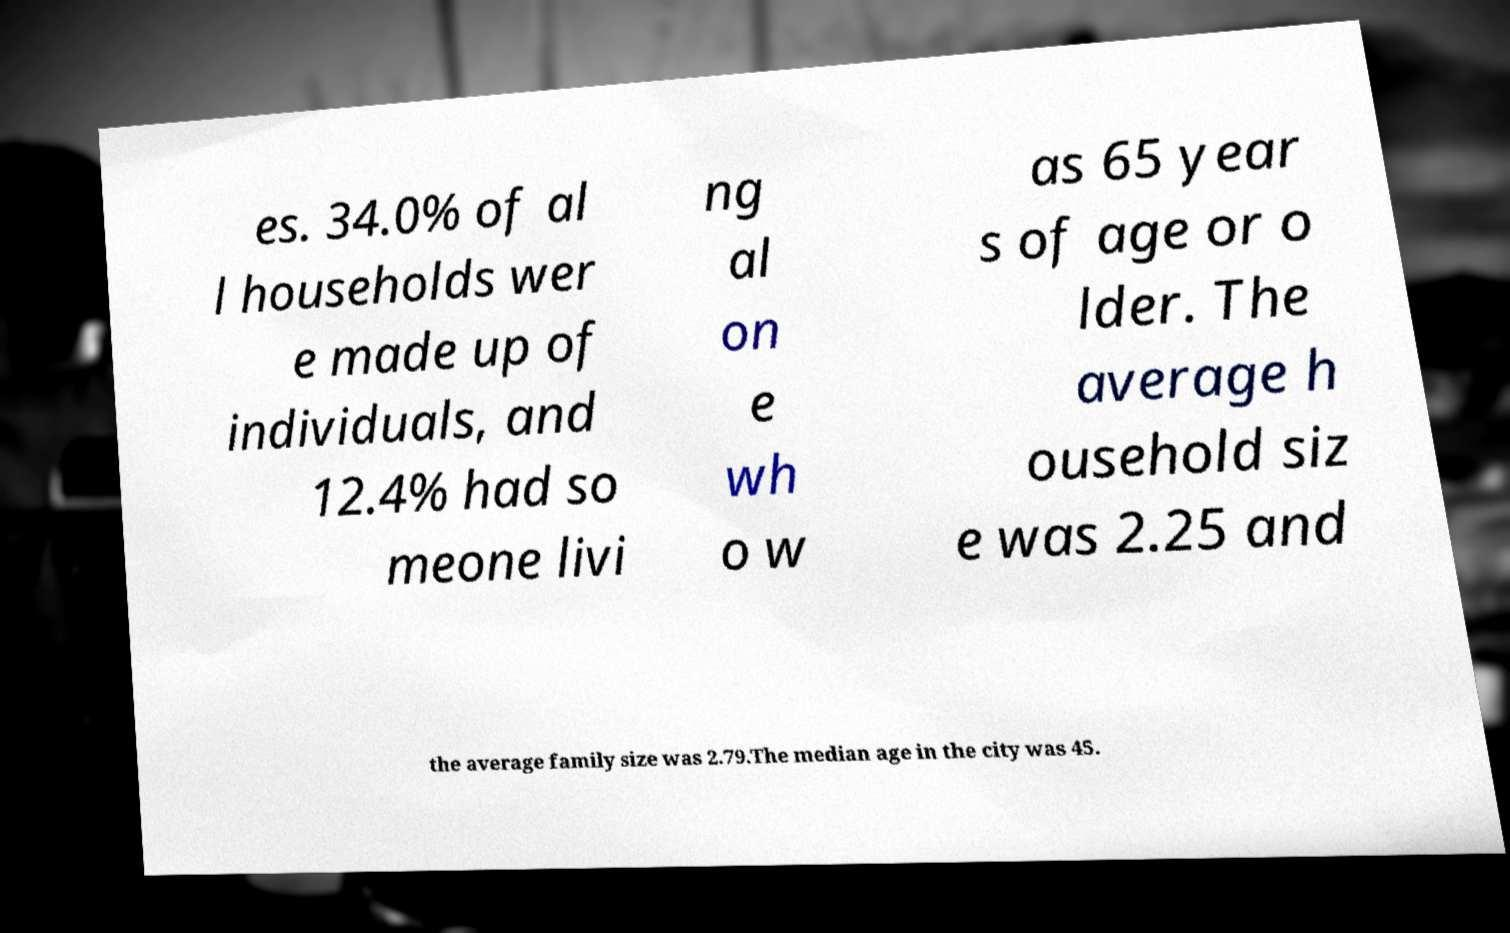I need the written content from this picture converted into text. Can you do that? es. 34.0% of al l households wer e made up of individuals, and 12.4% had so meone livi ng al on e wh o w as 65 year s of age or o lder. The average h ousehold siz e was 2.25 and the average family size was 2.79.The median age in the city was 45. 